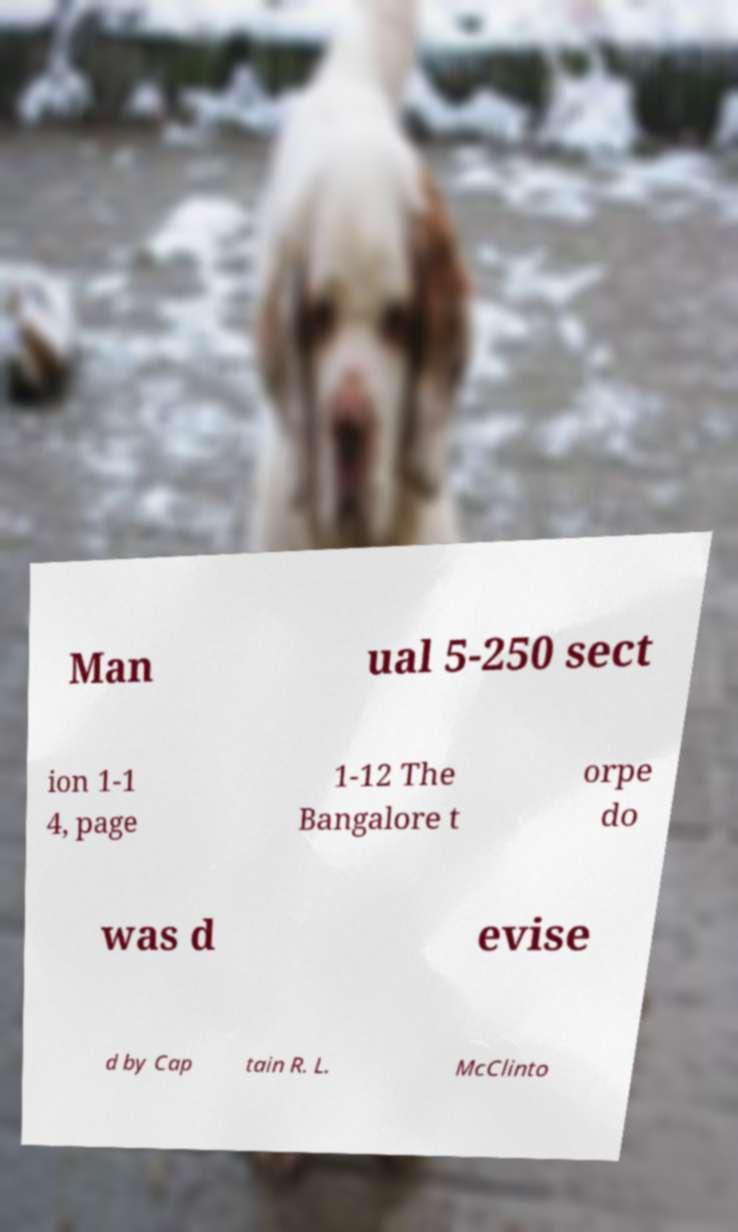I need the written content from this picture converted into text. Can you do that? Man ual 5-250 sect ion 1-1 4, page 1-12 The Bangalore t orpe do was d evise d by Cap tain R. L. McClinto 